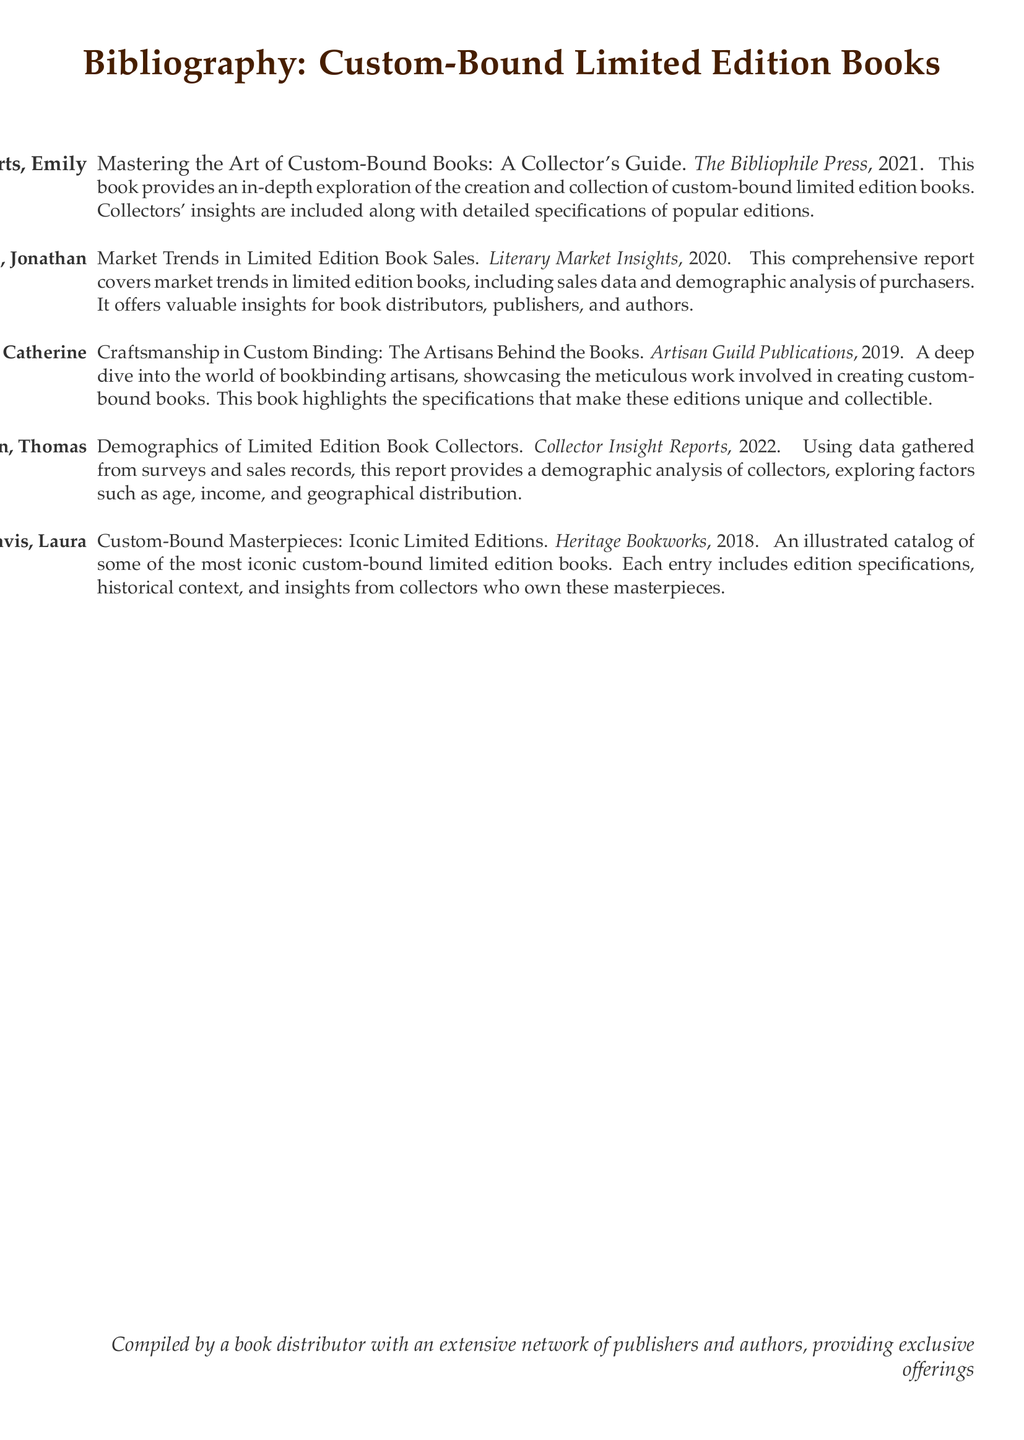What is the title of the first entry in the bibliography? The first entry in the bibliography is titled "Mastering the Art of Custom-Bound Books: A Collector's Guide."
Answer: Mastering the Art of Custom-Bound Books: A Collector's Guide Who is the author of "Market Trends in Limited Edition Book Sales"? The author of "Market Trends in Limited Edition Book Sales" is Jonathan Smith.
Answer: Jonathan Smith What year was "Demographics of Limited Edition Book Collectors" published? The publication year of "Demographics of Limited Edition Book Collectors" is 2022.
Answer: 2022 How many entries are listed in the bibliography? The total number of entries in the bibliography is five.
Answer: Five Which publisher published the book on craftsmanship in custom binding? The book on craftsmanship in custom binding was published by Artisan Guild Publications.
Answer: Artisan Guild Publications Which entry discusses the historical context of iconic limited editions? The entry that discusses the historical context is "Custom-Bound Masterpieces: Iconic Limited Editions."
Answer: Custom-Bound Masterpieces: Iconic Limited Editions What type of insights does "Market Trends in Limited Edition Book Sales" provide? It provides valuable insights for book distributors, publishers, and authors.
Answer: Valuable insights What does the bibliography provide information about? It provides information about custom-bound limited edition books, including specifications and collector insights.
Answer: Custom-bound limited edition books Which author's work includes insights from collectors? "Custom-Bound Masterpieces: Iconic Limited Editions" includes insights from collectors.
Answer: Laura Davis 